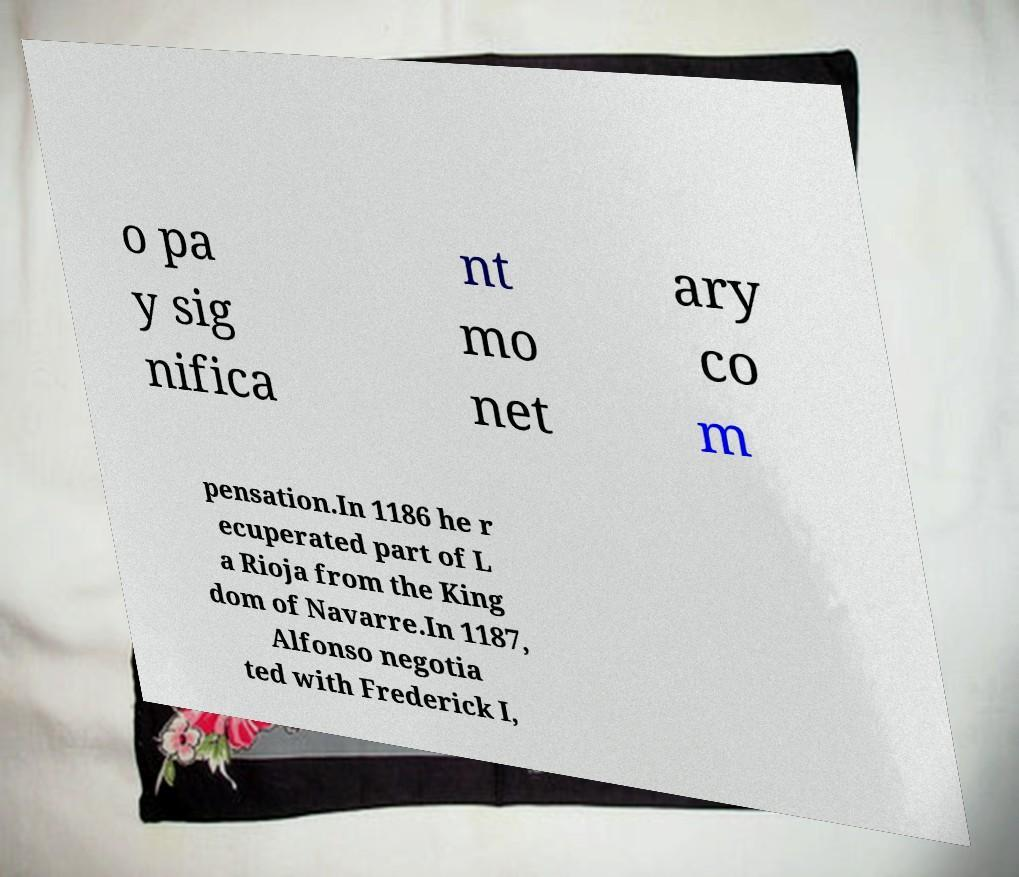I need the written content from this picture converted into text. Can you do that? o pa y sig nifica nt mo net ary co m pensation.In 1186 he r ecuperated part of L a Rioja from the King dom of Navarre.In 1187, Alfonso negotia ted with Frederick I, 